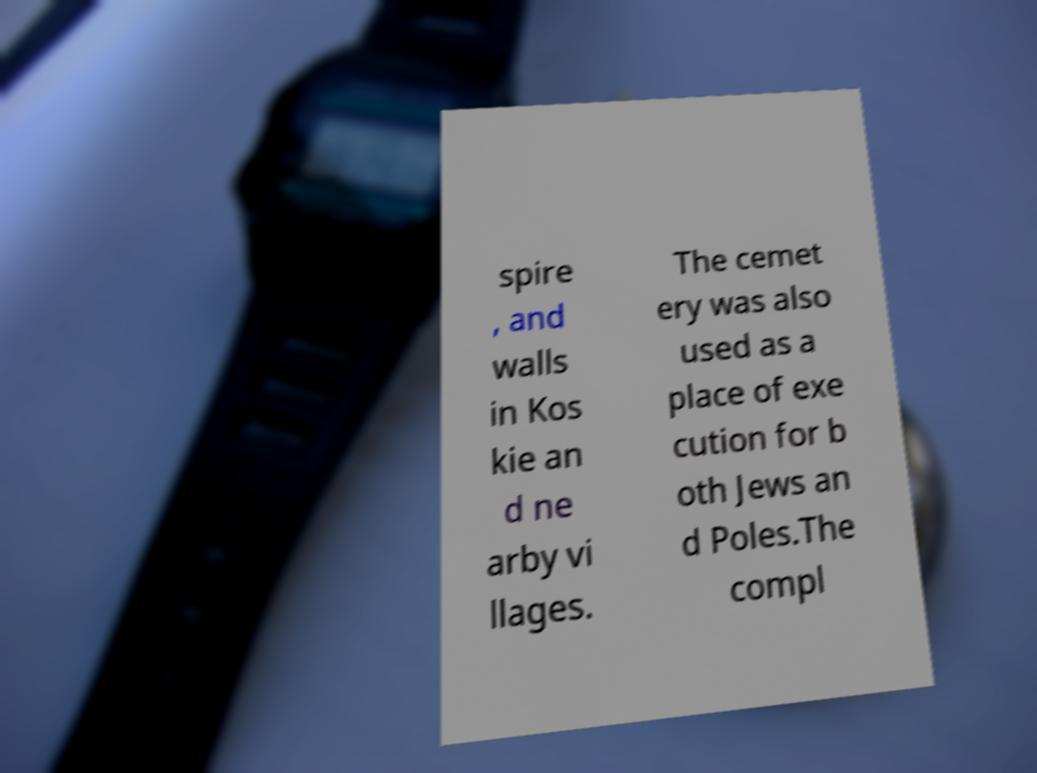Please identify and transcribe the text found in this image. spire , and walls in Kos kie an d ne arby vi llages. The cemet ery was also used as a place of exe cution for b oth Jews an d Poles.The compl 